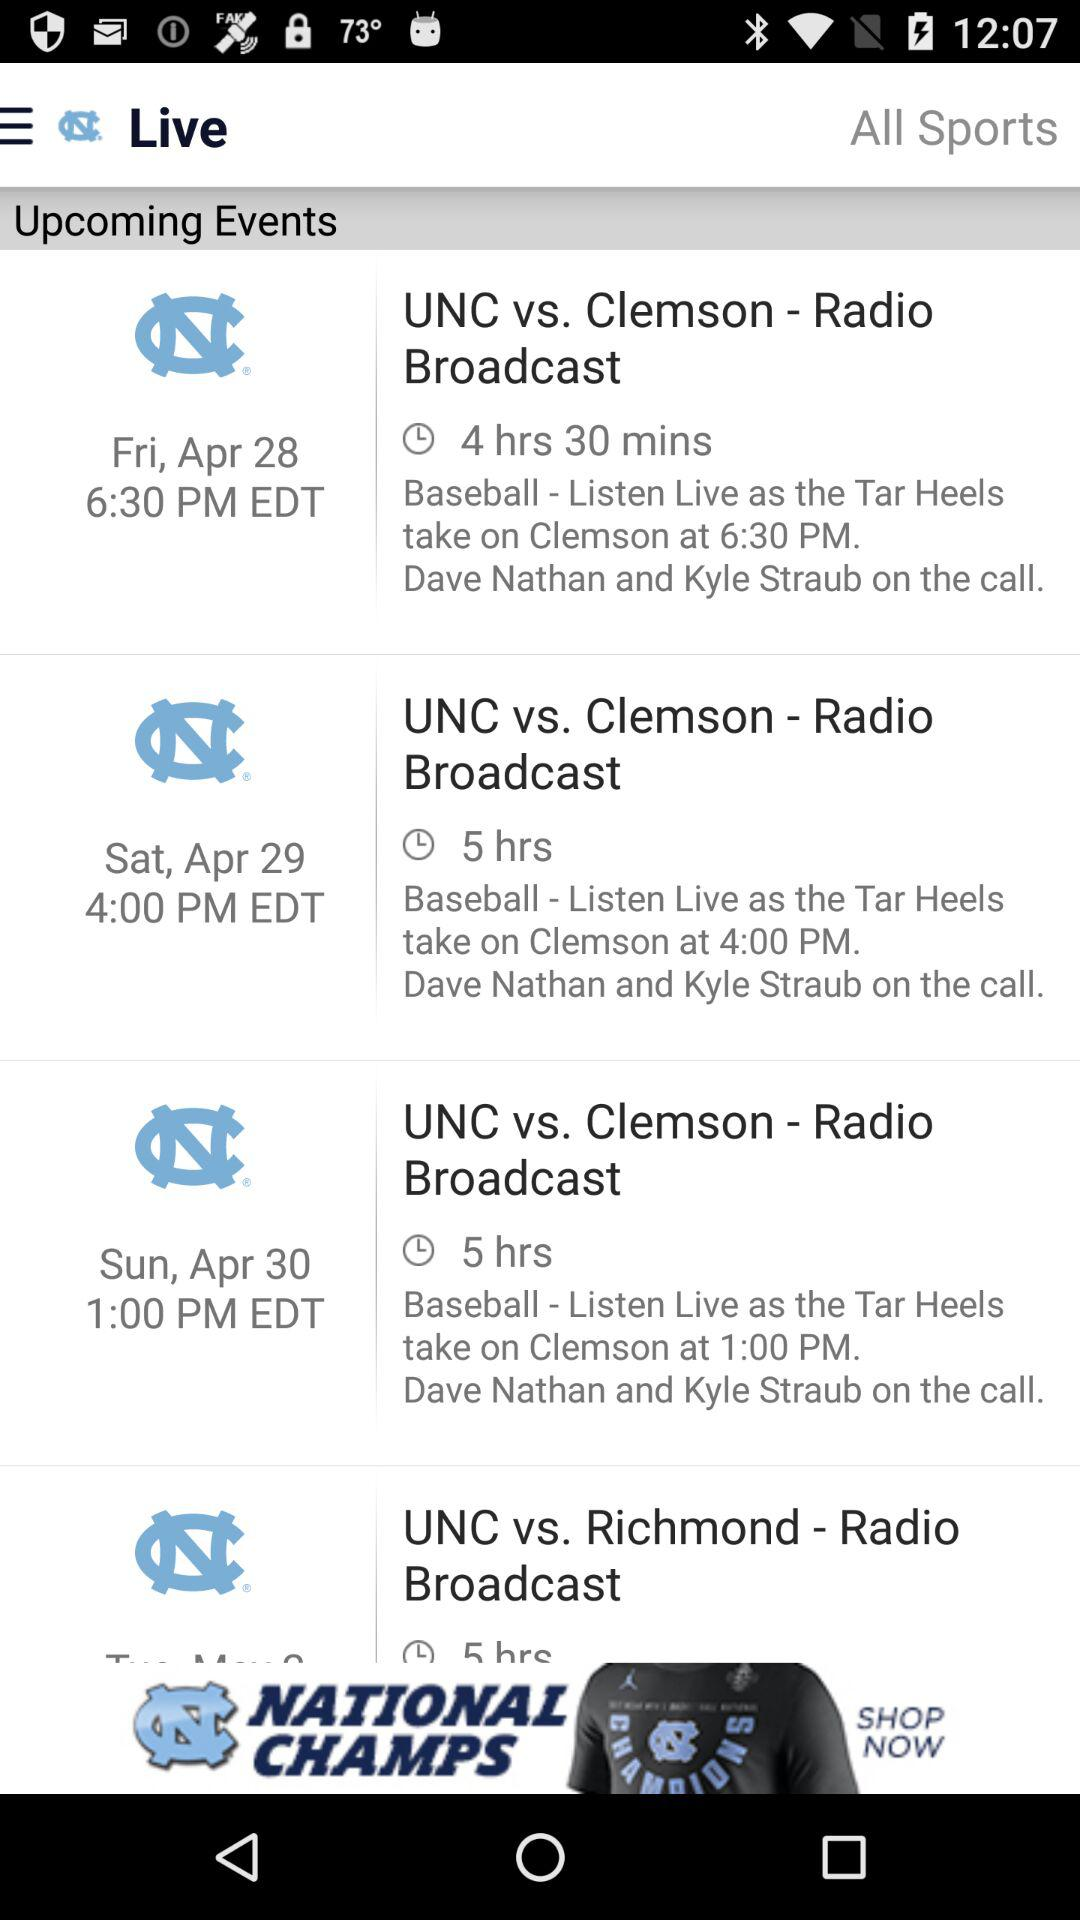When are the upcoming events for the "UNC vs. Clemson - Radio Broadcast"? The upcoming events are on Friday, April 28 at 6:30 p.m. EDT; Saturday, April 29 at 4:00 p.m. EDT and Sunday, April 30 at 1:00 p.m. EDT. 